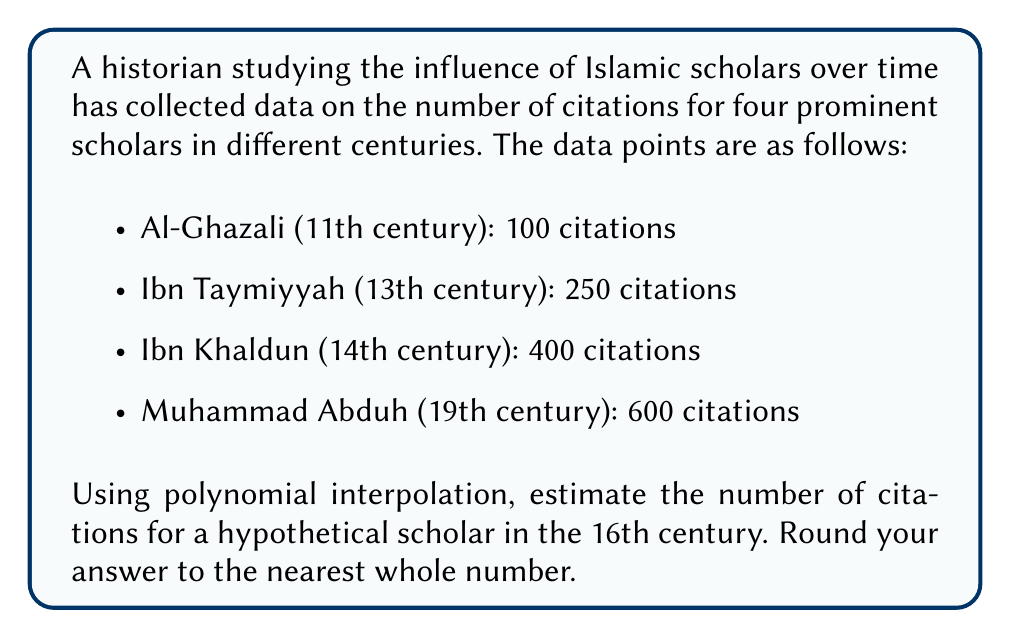Solve this math problem. To solve this problem, we'll use Lagrange polynomial interpolation. Let's follow these steps:

1) First, let's assign variables to our data points:
   $(x_1, y_1) = (11, 100)$, $(x_2, y_2) = (13, 250)$, $(x_3, y_3) = (14, 400)$, $(x_4, y_4) = (19, 600)$

2) The Lagrange interpolation polynomial is given by:
   $$P(x) = y_1L_1(x) + y_2L_2(x) + y_3L_3(x) + y_4L_4(x)$$

   where $L_i(x)$ are the Lagrange basis polynomials:

   $$L_i(x) = \prod_{j\neq i} \frac{x - x_j}{x_i - x_j}$$

3) Let's calculate each $L_i(x)$ for $x = 16$ (16th century):

   $$L_1(16) = \frac{(16-13)(16-14)(16-19)}{(11-13)(11-14)(11-19)} = -0.0667$$
   $$L_2(16) = \frac{(16-11)(16-14)(16-19)}{(13-11)(13-14)(13-19)} = 0.1333$$
   $$L_3(16) = \frac{(16-11)(16-13)(16-19)}{(14-11)(14-13)(14-19)} = 0.6000$$
   $$L_4(16) = \frac{(16-11)(16-13)(16-14)}{(19-11)(19-13)(19-14)} = 0.3333$$

4) Now we can calculate $P(16)$:

   $$P(16) = 100(-0.0667) + 250(0.1333) + 400(0.6000) + 600(0.3333)$$
   $$= -6.67 + 33.33 + 240 + 200 = 466.66$$

5) Rounding to the nearest whole number, we get 467.
Answer: 467 citations 